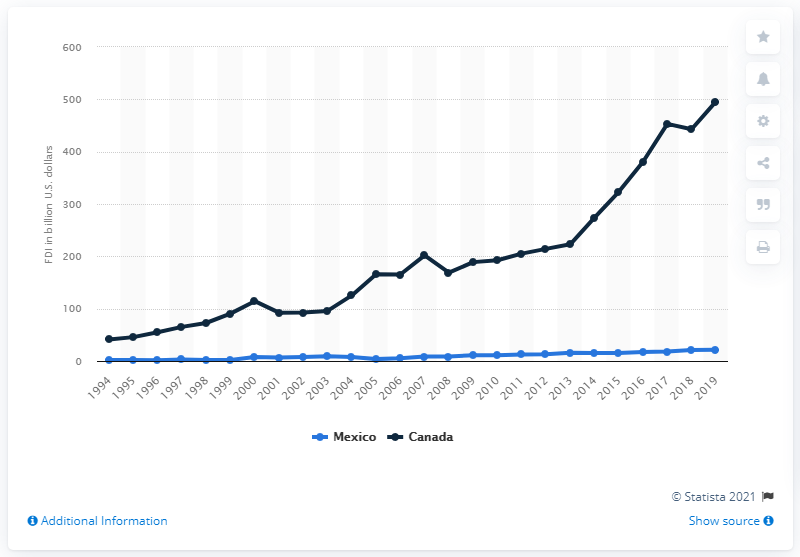Highlight a few significant elements in this photo. In 2019, Canada made the most direct investments in the United States. In 2019, Canada invested a total of 495.72 in the United States. 